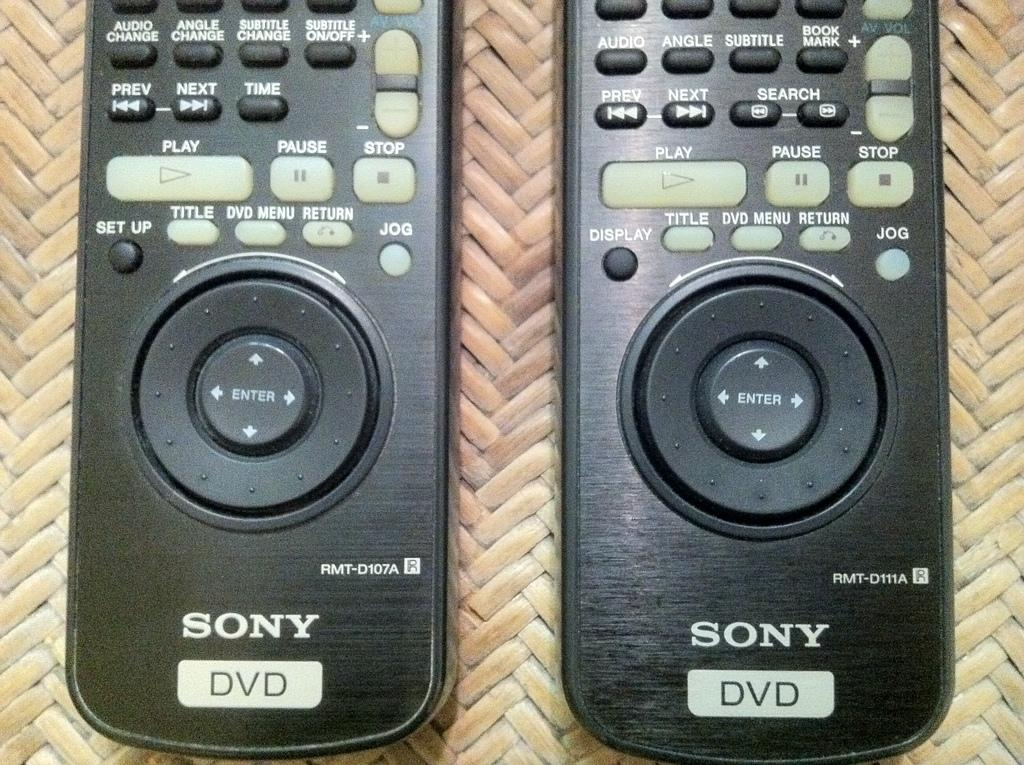<image>
Write a terse but informative summary of the picture. Two controllers next to one another both saying Sony on the bottom. 